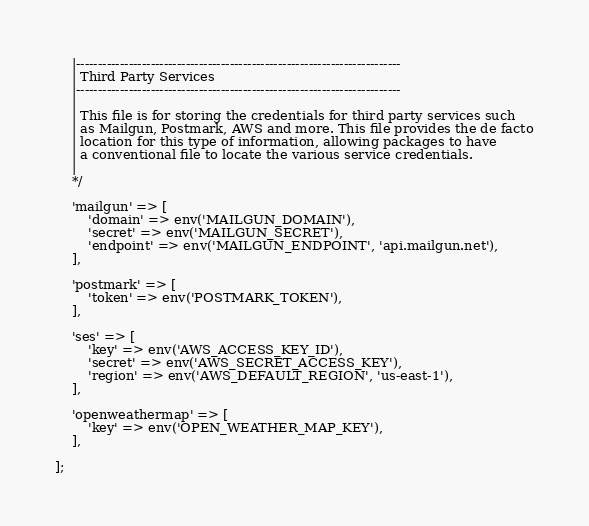Convert code to text. <code><loc_0><loc_0><loc_500><loc_500><_PHP_>    |--------------------------------------------------------------------------
    | Third Party Services
    |--------------------------------------------------------------------------
    |
    | This file is for storing the credentials for third party services such
    | as Mailgun, Postmark, AWS and more. This file provides the de facto
    | location for this type of information, allowing packages to have
    | a conventional file to locate the various service credentials.
    |
    */

    'mailgun' => [
        'domain' => env('MAILGUN_DOMAIN'),
        'secret' => env('MAILGUN_SECRET'),
        'endpoint' => env('MAILGUN_ENDPOINT', 'api.mailgun.net'),
    ],

    'postmark' => [
        'token' => env('POSTMARK_TOKEN'),
    ],

    'ses' => [
        'key' => env('AWS_ACCESS_KEY_ID'),
        'secret' => env('AWS_SECRET_ACCESS_KEY'),
        'region' => env('AWS_DEFAULT_REGION', 'us-east-1'),
    ],

    'openweathermap' => [
        'key' => env('OPEN_WEATHER_MAP_KEY'),
    ],

];
</code> 